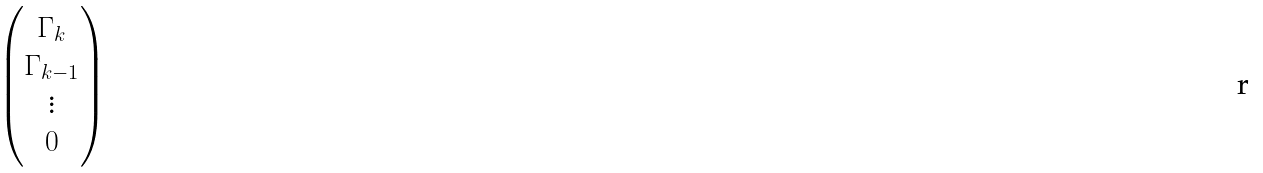<formula> <loc_0><loc_0><loc_500><loc_500>\begin{pmatrix} { \Gamma _ { k } } \\ { \Gamma _ { k - 1 } } \\ { \vdots } \\ { 0 } \end{pmatrix}</formula> 